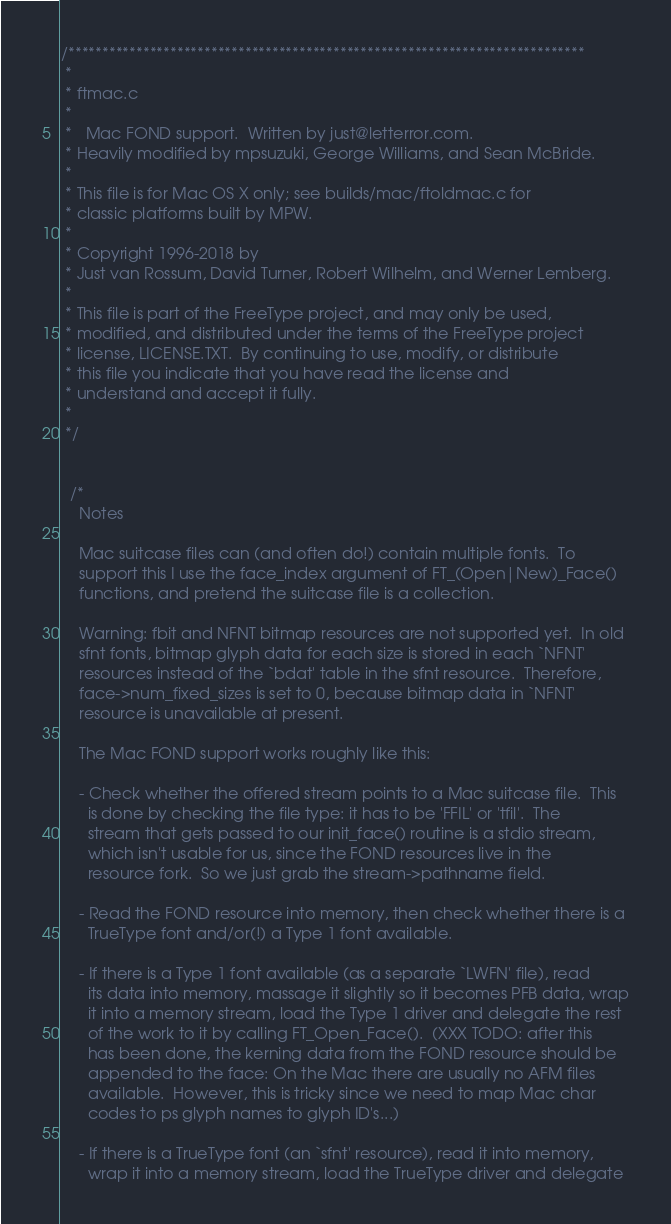Convert code to text. <code><loc_0><loc_0><loc_500><loc_500><_C_>/****************************************************************************
 *
 * ftmac.c
 *
 *   Mac FOND support.  Written by just@letterror.com.
 * Heavily modified by mpsuzuki, George Williams, and Sean McBride.
 *
 * This file is for Mac OS X only; see builds/mac/ftoldmac.c for
 * classic platforms built by MPW.
 *
 * Copyright 1996-2018 by
 * Just van Rossum, David Turner, Robert Wilhelm, and Werner Lemberg.
 *
 * This file is part of the FreeType project, and may only be used,
 * modified, and distributed under the terms of the FreeType project
 * license, LICENSE.TXT.  By continuing to use, modify, or distribute
 * this file you indicate that you have read the license and
 * understand and accept it fully.
 *
 */


  /*
    Notes

    Mac suitcase files can (and often do!) contain multiple fonts.  To
    support this I use the face_index argument of FT_(Open|New)_Face()
    functions, and pretend the suitcase file is a collection.

    Warning: fbit and NFNT bitmap resources are not supported yet.  In old
    sfnt fonts, bitmap glyph data for each size is stored in each `NFNT'
    resources instead of the `bdat' table in the sfnt resource.  Therefore,
    face->num_fixed_sizes is set to 0, because bitmap data in `NFNT'
    resource is unavailable at present.

    The Mac FOND support works roughly like this:

    - Check whether the offered stream points to a Mac suitcase file.  This
      is done by checking the file type: it has to be 'FFIL' or 'tfil'.  The
      stream that gets passed to our init_face() routine is a stdio stream,
      which isn't usable for us, since the FOND resources live in the
      resource fork.  So we just grab the stream->pathname field.

    - Read the FOND resource into memory, then check whether there is a
      TrueType font and/or(!) a Type 1 font available.

    - If there is a Type 1 font available (as a separate `LWFN' file), read
      its data into memory, massage it slightly so it becomes PFB data, wrap
      it into a memory stream, load the Type 1 driver and delegate the rest
      of the work to it by calling FT_Open_Face().  (XXX TODO: after this
      has been done, the kerning data from the FOND resource should be
      appended to the face: On the Mac there are usually no AFM files
      available.  However, this is tricky since we need to map Mac char
      codes to ps glyph names to glyph ID's...)

    - If there is a TrueType font (an `sfnt' resource), read it into memory,
      wrap it into a memory stream, load the TrueType driver and delegate</code> 